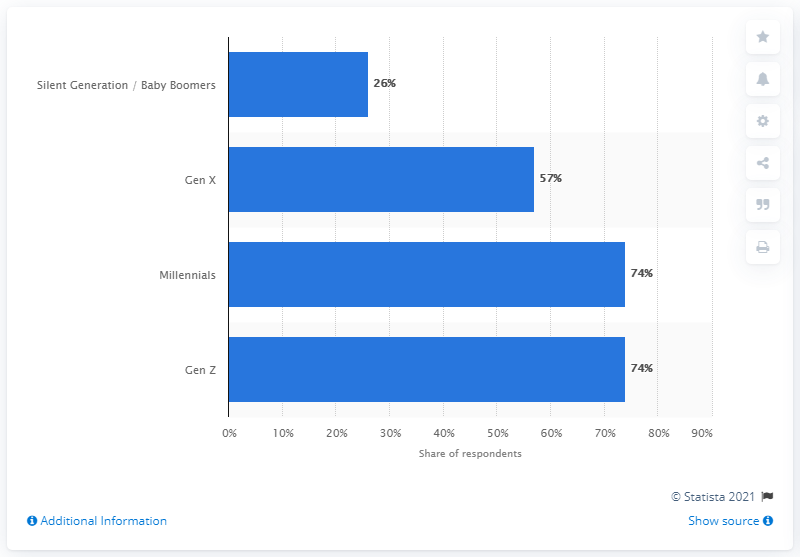Draw attention to some important aspects in this diagram. A majority of Gen X respondents, 57%, also reported feeling the same way. 